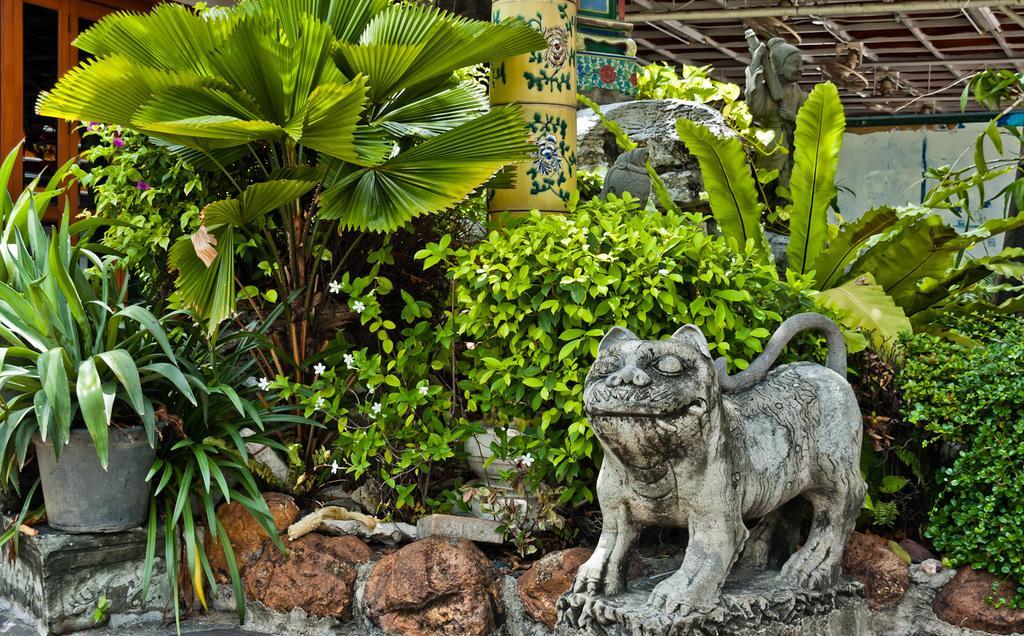Could you give a brief overview of what you see in this image? In this image there is a animal statue. Beside there are few rocks. Left side there is a pot on the rock. Pot is having few plants in it. Beside there are few plants having flowers. Behind there is a pillar and few statues. Left side there is a window. 